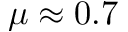<formula> <loc_0><loc_0><loc_500><loc_500>\mu \approx 0 . 7</formula> 